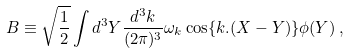Convert formula to latex. <formula><loc_0><loc_0><loc_500><loc_500>B \equiv \sqrt { \frac { 1 } { 2 } } \int d ^ { 3 } Y \frac { d ^ { 3 } k } { ( 2 \pi ) ^ { 3 } } \omega _ { k } \cos \{ k . ( X - Y ) \} \phi ( Y ) \, ,</formula> 